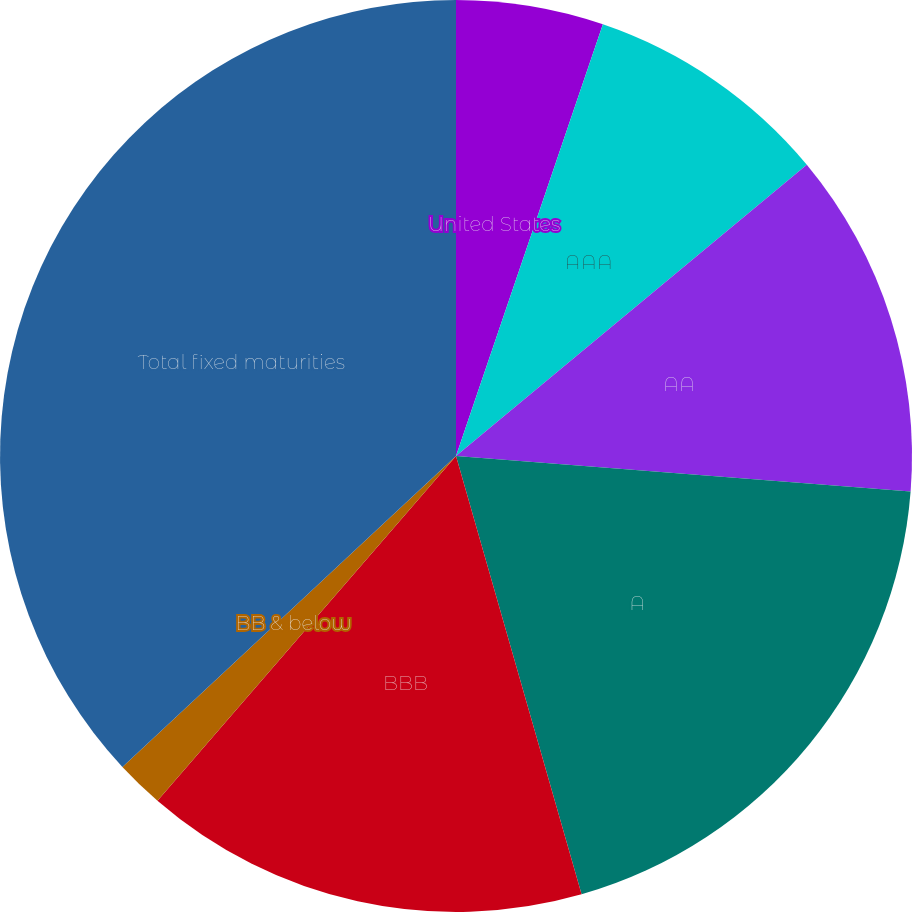<chart> <loc_0><loc_0><loc_500><loc_500><pie_chart><fcel>United States<fcel>AAA<fcel>AA<fcel>A<fcel>BBB<fcel>BB & below<fcel>Total fixed maturities<nl><fcel>5.22%<fcel>8.75%<fcel>12.27%<fcel>19.32%<fcel>15.8%<fcel>1.7%<fcel>36.94%<nl></chart> 